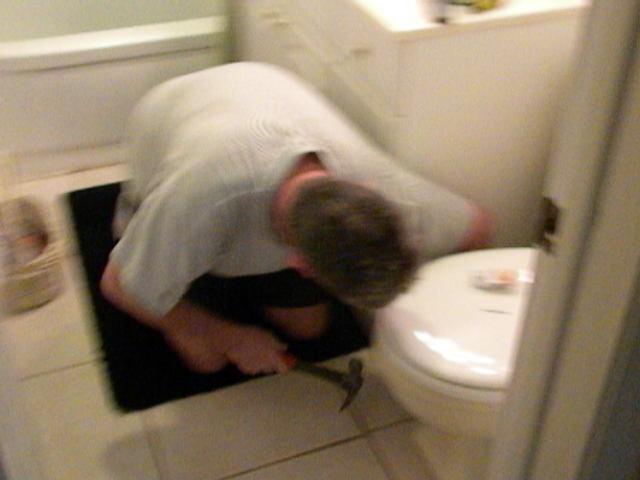What room is the person in?
Write a very short answer. Bathroom. What is the kneeling on?
Quick response, please. Mat. What is the guy gripping?
Give a very brief answer. Hammer. 